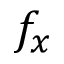<formula> <loc_0><loc_0><loc_500><loc_500>f _ { x }</formula> 